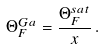Convert formula to latex. <formula><loc_0><loc_0><loc_500><loc_500>\Theta _ { F } ^ { G a } = \frac { \Theta _ { F } ^ { s a t } } { x } \, .</formula> 